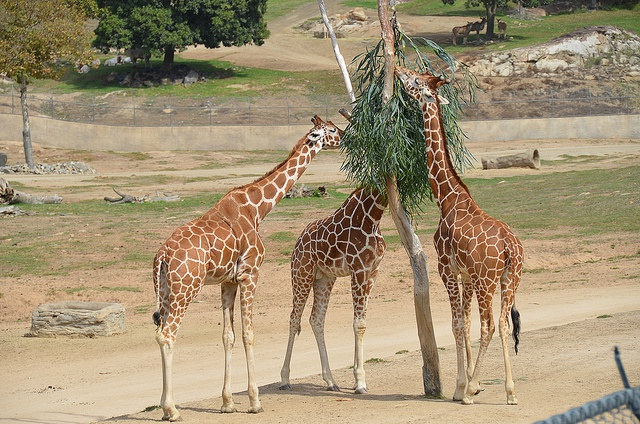Describe the objects in this image and their specific colors. I can see giraffe in gray, brown, and tan tones and giraffe in gray, maroon, and darkgray tones in this image. 